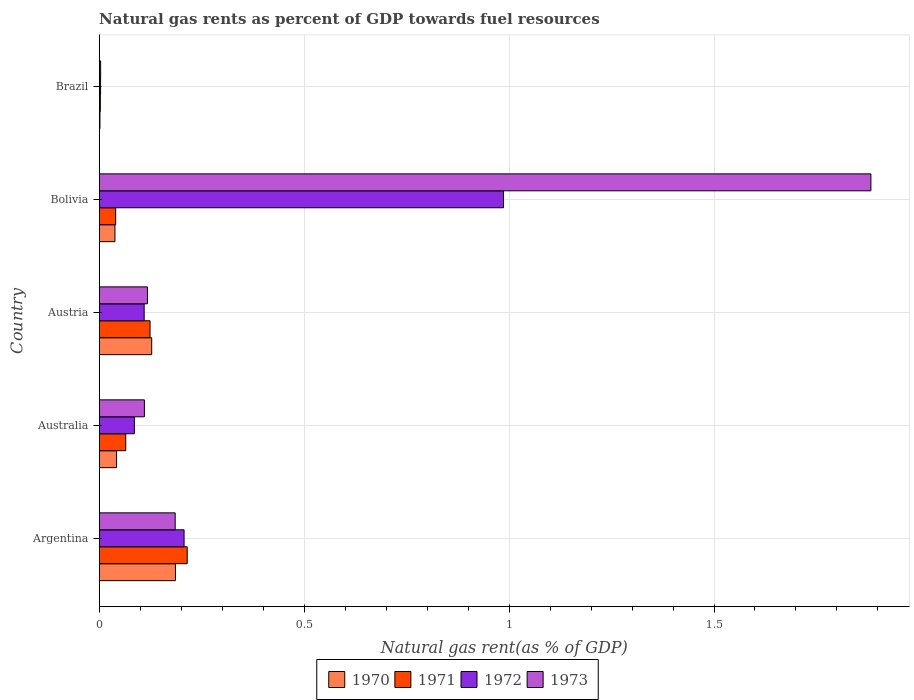How many different coloured bars are there?
Provide a succinct answer. 4. Are the number of bars on each tick of the Y-axis equal?
Keep it short and to the point. Yes. How many bars are there on the 2nd tick from the top?
Make the answer very short. 4. How many bars are there on the 4th tick from the bottom?
Ensure brevity in your answer.  4. In how many cases, is the number of bars for a given country not equal to the number of legend labels?
Your answer should be very brief. 0. What is the natural gas rent in 1972 in Bolivia?
Offer a terse response. 0.99. Across all countries, what is the maximum natural gas rent in 1972?
Your answer should be compact. 0.99. Across all countries, what is the minimum natural gas rent in 1970?
Provide a succinct answer. 0. What is the total natural gas rent in 1971 in the graph?
Offer a very short reply. 0.45. What is the difference between the natural gas rent in 1972 in Argentina and that in Australia?
Your response must be concise. 0.12. What is the difference between the natural gas rent in 1971 in Bolivia and the natural gas rent in 1970 in Argentina?
Offer a very short reply. -0.15. What is the average natural gas rent in 1972 per country?
Your answer should be compact. 0.28. What is the difference between the natural gas rent in 1970 and natural gas rent in 1972 in Bolivia?
Offer a very short reply. -0.95. What is the ratio of the natural gas rent in 1970 in Argentina to that in Brazil?
Offer a terse response. 104.59. Is the natural gas rent in 1970 in Australia less than that in Brazil?
Provide a succinct answer. No. Is the difference between the natural gas rent in 1970 in Australia and Bolivia greater than the difference between the natural gas rent in 1972 in Australia and Bolivia?
Offer a very short reply. Yes. What is the difference between the highest and the second highest natural gas rent in 1971?
Your response must be concise. 0.09. What is the difference between the highest and the lowest natural gas rent in 1973?
Keep it short and to the point. 1.88. Is the sum of the natural gas rent in 1973 in Australia and Austria greater than the maximum natural gas rent in 1970 across all countries?
Your response must be concise. Yes. What does the 4th bar from the bottom in Brazil represents?
Your response must be concise. 1973. How many bars are there?
Offer a terse response. 20. Are all the bars in the graph horizontal?
Offer a very short reply. Yes. Are the values on the major ticks of X-axis written in scientific E-notation?
Make the answer very short. No. Where does the legend appear in the graph?
Your answer should be compact. Bottom center. How many legend labels are there?
Offer a very short reply. 4. What is the title of the graph?
Ensure brevity in your answer.  Natural gas rents as percent of GDP towards fuel resources. Does "1971" appear as one of the legend labels in the graph?
Your answer should be compact. Yes. What is the label or title of the X-axis?
Offer a terse response. Natural gas rent(as % of GDP). What is the label or title of the Y-axis?
Your answer should be compact. Country. What is the Natural gas rent(as % of GDP) of 1970 in Argentina?
Provide a succinct answer. 0.19. What is the Natural gas rent(as % of GDP) in 1971 in Argentina?
Provide a succinct answer. 0.21. What is the Natural gas rent(as % of GDP) in 1972 in Argentina?
Your response must be concise. 0.21. What is the Natural gas rent(as % of GDP) in 1973 in Argentina?
Provide a short and direct response. 0.19. What is the Natural gas rent(as % of GDP) of 1970 in Australia?
Keep it short and to the point. 0.04. What is the Natural gas rent(as % of GDP) of 1971 in Australia?
Keep it short and to the point. 0.06. What is the Natural gas rent(as % of GDP) of 1972 in Australia?
Keep it short and to the point. 0.09. What is the Natural gas rent(as % of GDP) of 1973 in Australia?
Your response must be concise. 0.11. What is the Natural gas rent(as % of GDP) in 1970 in Austria?
Your answer should be compact. 0.13. What is the Natural gas rent(as % of GDP) in 1971 in Austria?
Your answer should be very brief. 0.12. What is the Natural gas rent(as % of GDP) in 1972 in Austria?
Give a very brief answer. 0.11. What is the Natural gas rent(as % of GDP) in 1973 in Austria?
Your answer should be compact. 0.12. What is the Natural gas rent(as % of GDP) in 1970 in Bolivia?
Make the answer very short. 0.04. What is the Natural gas rent(as % of GDP) in 1971 in Bolivia?
Keep it short and to the point. 0.04. What is the Natural gas rent(as % of GDP) of 1972 in Bolivia?
Your answer should be compact. 0.99. What is the Natural gas rent(as % of GDP) in 1973 in Bolivia?
Offer a terse response. 1.88. What is the Natural gas rent(as % of GDP) in 1970 in Brazil?
Your answer should be compact. 0. What is the Natural gas rent(as % of GDP) in 1971 in Brazil?
Offer a very short reply. 0. What is the Natural gas rent(as % of GDP) in 1972 in Brazil?
Ensure brevity in your answer.  0. What is the Natural gas rent(as % of GDP) in 1973 in Brazil?
Provide a short and direct response. 0. Across all countries, what is the maximum Natural gas rent(as % of GDP) of 1970?
Your answer should be compact. 0.19. Across all countries, what is the maximum Natural gas rent(as % of GDP) in 1971?
Give a very brief answer. 0.21. Across all countries, what is the maximum Natural gas rent(as % of GDP) of 1972?
Keep it short and to the point. 0.99. Across all countries, what is the maximum Natural gas rent(as % of GDP) in 1973?
Your response must be concise. 1.88. Across all countries, what is the minimum Natural gas rent(as % of GDP) of 1970?
Your response must be concise. 0. Across all countries, what is the minimum Natural gas rent(as % of GDP) in 1971?
Your answer should be compact. 0. Across all countries, what is the minimum Natural gas rent(as % of GDP) of 1972?
Your response must be concise. 0. Across all countries, what is the minimum Natural gas rent(as % of GDP) in 1973?
Ensure brevity in your answer.  0. What is the total Natural gas rent(as % of GDP) in 1970 in the graph?
Provide a short and direct response. 0.4. What is the total Natural gas rent(as % of GDP) in 1971 in the graph?
Ensure brevity in your answer.  0.45. What is the total Natural gas rent(as % of GDP) of 1972 in the graph?
Your answer should be very brief. 1.39. What is the total Natural gas rent(as % of GDP) of 1973 in the graph?
Provide a succinct answer. 2.3. What is the difference between the Natural gas rent(as % of GDP) of 1970 in Argentina and that in Australia?
Offer a very short reply. 0.14. What is the difference between the Natural gas rent(as % of GDP) of 1971 in Argentina and that in Australia?
Provide a succinct answer. 0.15. What is the difference between the Natural gas rent(as % of GDP) in 1972 in Argentina and that in Australia?
Your answer should be compact. 0.12. What is the difference between the Natural gas rent(as % of GDP) of 1973 in Argentina and that in Australia?
Provide a short and direct response. 0.08. What is the difference between the Natural gas rent(as % of GDP) of 1970 in Argentina and that in Austria?
Offer a very short reply. 0.06. What is the difference between the Natural gas rent(as % of GDP) of 1971 in Argentina and that in Austria?
Offer a very short reply. 0.09. What is the difference between the Natural gas rent(as % of GDP) of 1972 in Argentina and that in Austria?
Offer a terse response. 0.1. What is the difference between the Natural gas rent(as % of GDP) of 1973 in Argentina and that in Austria?
Provide a succinct answer. 0.07. What is the difference between the Natural gas rent(as % of GDP) in 1970 in Argentina and that in Bolivia?
Give a very brief answer. 0.15. What is the difference between the Natural gas rent(as % of GDP) in 1971 in Argentina and that in Bolivia?
Give a very brief answer. 0.17. What is the difference between the Natural gas rent(as % of GDP) of 1972 in Argentina and that in Bolivia?
Offer a terse response. -0.78. What is the difference between the Natural gas rent(as % of GDP) of 1973 in Argentina and that in Bolivia?
Make the answer very short. -1.7. What is the difference between the Natural gas rent(as % of GDP) of 1970 in Argentina and that in Brazil?
Your answer should be very brief. 0.18. What is the difference between the Natural gas rent(as % of GDP) in 1971 in Argentina and that in Brazil?
Your answer should be very brief. 0.21. What is the difference between the Natural gas rent(as % of GDP) in 1972 in Argentina and that in Brazil?
Provide a short and direct response. 0.2. What is the difference between the Natural gas rent(as % of GDP) of 1973 in Argentina and that in Brazil?
Provide a short and direct response. 0.18. What is the difference between the Natural gas rent(as % of GDP) in 1970 in Australia and that in Austria?
Offer a very short reply. -0.09. What is the difference between the Natural gas rent(as % of GDP) of 1971 in Australia and that in Austria?
Ensure brevity in your answer.  -0.06. What is the difference between the Natural gas rent(as % of GDP) of 1972 in Australia and that in Austria?
Your answer should be compact. -0.02. What is the difference between the Natural gas rent(as % of GDP) in 1973 in Australia and that in Austria?
Your answer should be very brief. -0.01. What is the difference between the Natural gas rent(as % of GDP) in 1970 in Australia and that in Bolivia?
Offer a very short reply. 0. What is the difference between the Natural gas rent(as % of GDP) of 1971 in Australia and that in Bolivia?
Your answer should be very brief. 0.02. What is the difference between the Natural gas rent(as % of GDP) in 1972 in Australia and that in Bolivia?
Provide a succinct answer. -0.9. What is the difference between the Natural gas rent(as % of GDP) of 1973 in Australia and that in Bolivia?
Your answer should be very brief. -1.77. What is the difference between the Natural gas rent(as % of GDP) of 1970 in Australia and that in Brazil?
Your answer should be very brief. 0.04. What is the difference between the Natural gas rent(as % of GDP) in 1971 in Australia and that in Brazil?
Keep it short and to the point. 0.06. What is the difference between the Natural gas rent(as % of GDP) of 1972 in Australia and that in Brazil?
Keep it short and to the point. 0.08. What is the difference between the Natural gas rent(as % of GDP) of 1973 in Australia and that in Brazil?
Make the answer very short. 0.11. What is the difference between the Natural gas rent(as % of GDP) of 1970 in Austria and that in Bolivia?
Your answer should be very brief. 0.09. What is the difference between the Natural gas rent(as % of GDP) in 1971 in Austria and that in Bolivia?
Ensure brevity in your answer.  0.08. What is the difference between the Natural gas rent(as % of GDP) in 1972 in Austria and that in Bolivia?
Give a very brief answer. -0.88. What is the difference between the Natural gas rent(as % of GDP) of 1973 in Austria and that in Bolivia?
Make the answer very short. -1.77. What is the difference between the Natural gas rent(as % of GDP) of 1970 in Austria and that in Brazil?
Your answer should be compact. 0.13. What is the difference between the Natural gas rent(as % of GDP) of 1971 in Austria and that in Brazil?
Give a very brief answer. 0.12. What is the difference between the Natural gas rent(as % of GDP) in 1972 in Austria and that in Brazil?
Make the answer very short. 0.11. What is the difference between the Natural gas rent(as % of GDP) of 1973 in Austria and that in Brazil?
Offer a terse response. 0.11. What is the difference between the Natural gas rent(as % of GDP) in 1970 in Bolivia and that in Brazil?
Your answer should be compact. 0.04. What is the difference between the Natural gas rent(as % of GDP) of 1971 in Bolivia and that in Brazil?
Your answer should be very brief. 0.04. What is the difference between the Natural gas rent(as % of GDP) in 1973 in Bolivia and that in Brazil?
Your answer should be very brief. 1.88. What is the difference between the Natural gas rent(as % of GDP) in 1970 in Argentina and the Natural gas rent(as % of GDP) in 1971 in Australia?
Keep it short and to the point. 0.12. What is the difference between the Natural gas rent(as % of GDP) of 1970 in Argentina and the Natural gas rent(as % of GDP) of 1972 in Australia?
Provide a succinct answer. 0.1. What is the difference between the Natural gas rent(as % of GDP) of 1970 in Argentina and the Natural gas rent(as % of GDP) of 1973 in Australia?
Your answer should be very brief. 0.08. What is the difference between the Natural gas rent(as % of GDP) of 1971 in Argentina and the Natural gas rent(as % of GDP) of 1972 in Australia?
Offer a very short reply. 0.13. What is the difference between the Natural gas rent(as % of GDP) in 1971 in Argentina and the Natural gas rent(as % of GDP) in 1973 in Australia?
Provide a short and direct response. 0.1. What is the difference between the Natural gas rent(as % of GDP) of 1972 in Argentina and the Natural gas rent(as % of GDP) of 1973 in Australia?
Offer a very short reply. 0.1. What is the difference between the Natural gas rent(as % of GDP) of 1970 in Argentina and the Natural gas rent(as % of GDP) of 1971 in Austria?
Offer a very short reply. 0.06. What is the difference between the Natural gas rent(as % of GDP) of 1970 in Argentina and the Natural gas rent(as % of GDP) of 1972 in Austria?
Offer a terse response. 0.08. What is the difference between the Natural gas rent(as % of GDP) in 1970 in Argentina and the Natural gas rent(as % of GDP) in 1973 in Austria?
Offer a very short reply. 0.07. What is the difference between the Natural gas rent(as % of GDP) of 1971 in Argentina and the Natural gas rent(as % of GDP) of 1972 in Austria?
Provide a succinct answer. 0.1. What is the difference between the Natural gas rent(as % of GDP) in 1971 in Argentina and the Natural gas rent(as % of GDP) in 1973 in Austria?
Provide a short and direct response. 0.1. What is the difference between the Natural gas rent(as % of GDP) of 1972 in Argentina and the Natural gas rent(as % of GDP) of 1973 in Austria?
Provide a short and direct response. 0.09. What is the difference between the Natural gas rent(as % of GDP) of 1970 in Argentina and the Natural gas rent(as % of GDP) of 1971 in Bolivia?
Your answer should be compact. 0.15. What is the difference between the Natural gas rent(as % of GDP) of 1970 in Argentina and the Natural gas rent(as % of GDP) of 1972 in Bolivia?
Your answer should be compact. -0.8. What is the difference between the Natural gas rent(as % of GDP) in 1970 in Argentina and the Natural gas rent(as % of GDP) in 1973 in Bolivia?
Your response must be concise. -1.7. What is the difference between the Natural gas rent(as % of GDP) of 1971 in Argentina and the Natural gas rent(as % of GDP) of 1972 in Bolivia?
Provide a short and direct response. -0.77. What is the difference between the Natural gas rent(as % of GDP) in 1971 in Argentina and the Natural gas rent(as % of GDP) in 1973 in Bolivia?
Make the answer very short. -1.67. What is the difference between the Natural gas rent(as % of GDP) of 1972 in Argentina and the Natural gas rent(as % of GDP) of 1973 in Bolivia?
Keep it short and to the point. -1.68. What is the difference between the Natural gas rent(as % of GDP) in 1970 in Argentina and the Natural gas rent(as % of GDP) in 1971 in Brazil?
Provide a succinct answer. 0.18. What is the difference between the Natural gas rent(as % of GDP) of 1970 in Argentina and the Natural gas rent(as % of GDP) of 1972 in Brazil?
Make the answer very short. 0.18. What is the difference between the Natural gas rent(as % of GDP) in 1970 in Argentina and the Natural gas rent(as % of GDP) in 1973 in Brazil?
Offer a terse response. 0.18. What is the difference between the Natural gas rent(as % of GDP) in 1971 in Argentina and the Natural gas rent(as % of GDP) in 1972 in Brazil?
Offer a terse response. 0.21. What is the difference between the Natural gas rent(as % of GDP) of 1971 in Argentina and the Natural gas rent(as % of GDP) of 1973 in Brazil?
Give a very brief answer. 0.21. What is the difference between the Natural gas rent(as % of GDP) in 1972 in Argentina and the Natural gas rent(as % of GDP) in 1973 in Brazil?
Keep it short and to the point. 0.2. What is the difference between the Natural gas rent(as % of GDP) in 1970 in Australia and the Natural gas rent(as % of GDP) in 1971 in Austria?
Provide a succinct answer. -0.08. What is the difference between the Natural gas rent(as % of GDP) in 1970 in Australia and the Natural gas rent(as % of GDP) in 1972 in Austria?
Make the answer very short. -0.07. What is the difference between the Natural gas rent(as % of GDP) in 1970 in Australia and the Natural gas rent(as % of GDP) in 1973 in Austria?
Ensure brevity in your answer.  -0.08. What is the difference between the Natural gas rent(as % of GDP) of 1971 in Australia and the Natural gas rent(as % of GDP) of 1972 in Austria?
Give a very brief answer. -0.04. What is the difference between the Natural gas rent(as % of GDP) of 1971 in Australia and the Natural gas rent(as % of GDP) of 1973 in Austria?
Your response must be concise. -0.05. What is the difference between the Natural gas rent(as % of GDP) in 1972 in Australia and the Natural gas rent(as % of GDP) in 1973 in Austria?
Your answer should be compact. -0.03. What is the difference between the Natural gas rent(as % of GDP) of 1970 in Australia and the Natural gas rent(as % of GDP) of 1971 in Bolivia?
Your answer should be compact. 0. What is the difference between the Natural gas rent(as % of GDP) of 1970 in Australia and the Natural gas rent(as % of GDP) of 1972 in Bolivia?
Give a very brief answer. -0.94. What is the difference between the Natural gas rent(as % of GDP) in 1970 in Australia and the Natural gas rent(as % of GDP) in 1973 in Bolivia?
Provide a short and direct response. -1.84. What is the difference between the Natural gas rent(as % of GDP) of 1971 in Australia and the Natural gas rent(as % of GDP) of 1972 in Bolivia?
Make the answer very short. -0.92. What is the difference between the Natural gas rent(as % of GDP) in 1971 in Australia and the Natural gas rent(as % of GDP) in 1973 in Bolivia?
Make the answer very short. -1.82. What is the difference between the Natural gas rent(as % of GDP) in 1972 in Australia and the Natural gas rent(as % of GDP) in 1973 in Bolivia?
Offer a terse response. -1.8. What is the difference between the Natural gas rent(as % of GDP) in 1970 in Australia and the Natural gas rent(as % of GDP) in 1971 in Brazil?
Offer a very short reply. 0.04. What is the difference between the Natural gas rent(as % of GDP) of 1970 in Australia and the Natural gas rent(as % of GDP) of 1972 in Brazil?
Keep it short and to the point. 0.04. What is the difference between the Natural gas rent(as % of GDP) of 1970 in Australia and the Natural gas rent(as % of GDP) of 1973 in Brazil?
Your answer should be compact. 0.04. What is the difference between the Natural gas rent(as % of GDP) of 1971 in Australia and the Natural gas rent(as % of GDP) of 1972 in Brazil?
Provide a succinct answer. 0.06. What is the difference between the Natural gas rent(as % of GDP) of 1971 in Australia and the Natural gas rent(as % of GDP) of 1973 in Brazil?
Your answer should be very brief. 0.06. What is the difference between the Natural gas rent(as % of GDP) of 1972 in Australia and the Natural gas rent(as % of GDP) of 1973 in Brazil?
Your answer should be compact. 0.08. What is the difference between the Natural gas rent(as % of GDP) in 1970 in Austria and the Natural gas rent(as % of GDP) in 1971 in Bolivia?
Keep it short and to the point. 0.09. What is the difference between the Natural gas rent(as % of GDP) of 1970 in Austria and the Natural gas rent(as % of GDP) of 1972 in Bolivia?
Provide a short and direct response. -0.86. What is the difference between the Natural gas rent(as % of GDP) of 1970 in Austria and the Natural gas rent(as % of GDP) of 1973 in Bolivia?
Ensure brevity in your answer.  -1.75. What is the difference between the Natural gas rent(as % of GDP) of 1971 in Austria and the Natural gas rent(as % of GDP) of 1972 in Bolivia?
Offer a terse response. -0.86. What is the difference between the Natural gas rent(as % of GDP) of 1971 in Austria and the Natural gas rent(as % of GDP) of 1973 in Bolivia?
Keep it short and to the point. -1.76. What is the difference between the Natural gas rent(as % of GDP) in 1972 in Austria and the Natural gas rent(as % of GDP) in 1973 in Bolivia?
Give a very brief answer. -1.77. What is the difference between the Natural gas rent(as % of GDP) in 1970 in Austria and the Natural gas rent(as % of GDP) in 1971 in Brazil?
Give a very brief answer. 0.13. What is the difference between the Natural gas rent(as % of GDP) in 1970 in Austria and the Natural gas rent(as % of GDP) in 1972 in Brazil?
Ensure brevity in your answer.  0.12. What is the difference between the Natural gas rent(as % of GDP) of 1970 in Austria and the Natural gas rent(as % of GDP) of 1973 in Brazil?
Your answer should be compact. 0.12. What is the difference between the Natural gas rent(as % of GDP) in 1971 in Austria and the Natural gas rent(as % of GDP) in 1972 in Brazil?
Make the answer very short. 0.12. What is the difference between the Natural gas rent(as % of GDP) of 1971 in Austria and the Natural gas rent(as % of GDP) of 1973 in Brazil?
Provide a short and direct response. 0.12. What is the difference between the Natural gas rent(as % of GDP) in 1972 in Austria and the Natural gas rent(as % of GDP) in 1973 in Brazil?
Give a very brief answer. 0.11. What is the difference between the Natural gas rent(as % of GDP) in 1970 in Bolivia and the Natural gas rent(as % of GDP) in 1971 in Brazil?
Your response must be concise. 0.04. What is the difference between the Natural gas rent(as % of GDP) of 1970 in Bolivia and the Natural gas rent(as % of GDP) of 1972 in Brazil?
Make the answer very short. 0.04. What is the difference between the Natural gas rent(as % of GDP) in 1970 in Bolivia and the Natural gas rent(as % of GDP) in 1973 in Brazil?
Offer a very short reply. 0.03. What is the difference between the Natural gas rent(as % of GDP) in 1971 in Bolivia and the Natural gas rent(as % of GDP) in 1972 in Brazil?
Your response must be concise. 0.04. What is the difference between the Natural gas rent(as % of GDP) of 1971 in Bolivia and the Natural gas rent(as % of GDP) of 1973 in Brazil?
Provide a short and direct response. 0.04. What is the difference between the Natural gas rent(as % of GDP) of 1972 in Bolivia and the Natural gas rent(as % of GDP) of 1973 in Brazil?
Give a very brief answer. 0.98. What is the average Natural gas rent(as % of GDP) of 1970 per country?
Provide a short and direct response. 0.08. What is the average Natural gas rent(as % of GDP) in 1971 per country?
Provide a succinct answer. 0.09. What is the average Natural gas rent(as % of GDP) in 1972 per country?
Offer a very short reply. 0.28. What is the average Natural gas rent(as % of GDP) in 1973 per country?
Your response must be concise. 0.46. What is the difference between the Natural gas rent(as % of GDP) of 1970 and Natural gas rent(as % of GDP) of 1971 in Argentina?
Keep it short and to the point. -0.03. What is the difference between the Natural gas rent(as % of GDP) in 1970 and Natural gas rent(as % of GDP) in 1972 in Argentina?
Your response must be concise. -0.02. What is the difference between the Natural gas rent(as % of GDP) of 1970 and Natural gas rent(as % of GDP) of 1973 in Argentina?
Provide a short and direct response. 0. What is the difference between the Natural gas rent(as % of GDP) in 1971 and Natural gas rent(as % of GDP) in 1972 in Argentina?
Provide a short and direct response. 0.01. What is the difference between the Natural gas rent(as % of GDP) in 1971 and Natural gas rent(as % of GDP) in 1973 in Argentina?
Provide a succinct answer. 0.03. What is the difference between the Natural gas rent(as % of GDP) of 1972 and Natural gas rent(as % of GDP) of 1973 in Argentina?
Your response must be concise. 0.02. What is the difference between the Natural gas rent(as % of GDP) in 1970 and Natural gas rent(as % of GDP) in 1971 in Australia?
Offer a very short reply. -0.02. What is the difference between the Natural gas rent(as % of GDP) of 1970 and Natural gas rent(as % of GDP) of 1972 in Australia?
Offer a very short reply. -0.04. What is the difference between the Natural gas rent(as % of GDP) in 1970 and Natural gas rent(as % of GDP) in 1973 in Australia?
Make the answer very short. -0.07. What is the difference between the Natural gas rent(as % of GDP) of 1971 and Natural gas rent(as % of GDP) of 1972 in Australia?
Your answer should be very brief. -0.02. What is the difference between the Natural gas rent(as % of GDP) of 1971 and Natural gas rent(as % of GDP) of 1973 in Australia?
Provide a short and direct response. -0.05. What is the difference between the Natural gas rent(as % of GDP) in 1972 and Natural gas rent(as % of GDP) in 1973 in Australia?
Offer a very short reply. -0.02. What is the difference between the Natural gas rent(as % of GDP) in 1970 and Natural gas rent(as % of GDP) in 1971 in Austria?
Give a very brief answer. 0. What is the difference between the Natural gas rent(as % of GDP) in 1970 and Natural gas rent(as % of GDP) in 1972 in Austria?
Keep it short and to the point. 0.02. What is the difference between the Natural gas rent(as % of GDP) of 1970 and Natural gas rent(as % of GDP) of 1973 in Austria?
Ensure brevity in your answer.  0.01. What is the difference between the Natural gas rent(as % of GDP) of 1971 and Natural gas rent(as % of GDP) of 1972 in Austria?
Offer a terse response. 0.01. What is the difference between the Natural gas rent(as % of GDP) of 1971 and Natural gas rent(as % of GDP) of 1973 in Austria?
Offer a very short reply. 0.01. What is the difference between the Natural gas rent(as % of GDP) of 1972 and Natural gas rent(as % of GDP) of 1973 in Austria?
Keep it short and to the point. -0.01. What is the difference between the Natural gas rent(as % of GDP) of 1970 and Natural gas rent(as % of GDP) of 1971 in Bolivia?
Your answer should be compact. -0. What is the difference between the Natural gas rent(as % of GDP) in 1970 and Natural gas rent(as % of GDP) in 1972 in Bolivia?
Offer a terse response. -0.95. What is the difference between the Natural gas rent(as % of GDP) in 1970 and Natural gas rent(as % of GDP) in 1973 in Bolivia?
Your answer should be very brief. -1.84. What is the difference between the Natural gas rent(as % of GDP) of 1971 and Natural gas rent(as % of GDP) of 1972 in Bolivia?
Keep it short and to the point. -0.95. What is the difference between the Natural gas rent(as % of GDP) of 1971 and Natural gas rent(as % of GDP) of 1973 in Bolivia?
Your response must be concise. -1.84. What is the difference between the Natural gas rent(as % of GDP) in 1972 and Natural gas rent(as % of GDP) in 1973 in Bolivia?
Ensure brevity in your answer.  -0.9. What is the difference between the Natural gas rent(as % of GDP) of 1970 and Natural gas rent(as % of GDP) of 1971 in Brazil?
Ensure brevity in your answer.  -0. What is the difference between the Natural gas rent(as % of GDP) in 1970 and Natural gas rent(as % of GDP) in 1972 in Brazil?
Make the answer very short. -0. What is the difference between the Natural gas rent(as % of GDP) of 1970 and Natural gas rent(as % of GDP) of 1973 in Brazil?
Provide a short and direct response. -0. What is the difference between the Natural gas rent(as % of GDP) of 1971 and Natural gas rent(as % of GDP) of 1972 in Brazil?
Make the answer very short. -0. What is the difference between the Natural gas rent(as % of GDP) in 1971 and Natural gas rent(as % of GDP) in 1973 in Brazil?
Provide a short and direct response. -0. What is the difference between the Natural gas rent(as % of GDP) in 1972 and Natural gas rent(as % of GDP) in 1973 in Brazil?
Your answer should be very brief. -0. What is the ratio of the Natural gas rent(as % of GDP) of 1970 in Argentina to that in Australia?
Provide a short and direct response. 4.39. What is the ratio of the Natural gas rent(as % of GDP) in 1971 in Argentina to that in Australia?
Provide a short and direct response. 3.32. What is the ratio of the Natural gas rent(as % of GDP) of 1972 in Argentina to that in Australia?
Give a very brief answer. 2.41. What is the ratio of the Natural gas rent(as % of GDP) in 1973 in Argentina to that in Australia?
Make the answer very short. 1.68. What is the ratio of the Natural gas rent(as % of GDP) in 1970 in Argentina to that in Austria?
Provide a succinct answer. 1.45. What is the ratio of the Natural gas rent(as % of GDP) in 1971 in Argentina to that in Austria?
Keep it short and to the point. 1.73. What is the ratio of the Natural gas rent(as % of GDP) in 1972 in Argentina to that in Austria?
Give a very brief answer. 1.89. What is the ratio of the Natural gas rent(as % of GDP) of 1973 in Argentina to that in Austria?
Offer a very short reply. 1.57. What is the ratio of the Natural gas rent(as % of GDP) in 1970 in Argentina to that in Bolivia?
Your response must be concise. 4.85. What is the ratio of the Natural gas rent(as % of GDP) of 1971 in Argentina to that in Bolivia?
Provide a short and direct response. 5.35. What is the ratio of the Natural gas rent(as % of GDP) in 1972 in Argentina to that in Bolivia?
Provide a succinct answer. 0.21. What is the ratio of the Natural gas rent(as % of GDP) of 1973 in Argentina to that in Bolivia?
Your answer should be very brief. 0.1. What is the ratio of the Natural gas rent(as % of GDP) in 1970 in Argentina to that in Brazil?
Give a very brief answer. 104.59. What is the ratio of the Natural gas rent(as % of GDP) in 1971 in Argentina to that in Brazil?
Your answer should be compact. 78.25. What is the ratio of the Natural gas rent(as % of GDP) in 1972 in Argentina to that in Brazil?
Your answer should be compact. 62.44. What is the ratio of the Natural gas rent(as % of GDP) of 1973 in Argentina to that in Brazil?
Offer a terse response. 53.1. What is the ratio of the Natural gas rent(as % of GDP) of 1970 in Australia to that in Austria?
Ensure brevity in your answer.  0.33. What is the ratio of the Natural gas rent(as % of GDP) of 1971 in Australia to that in Austria?
Offer a terse response. 0.52. What is the ratio of the Natural gas rent(as % of GDP) of 1972 in Australia to that in Austria?
Your response must be concise. 0.78. What is the ratio of the Natural gas rent(as % of GDP) of 1973 in Australia to that in Austria?
Your response must be concise. 0.94. What is the ratio of the Natural gas rent(as % of GDP) in 1970 in Australia to that in Bolivia?
Your response must be concise. 1.1. What is the ratio of the Natural gas rent(as % of GDP) of 1971 in Australia to that in Bolivia?
Provide a succinct answer. 1.61. What is the ratio of the Natural gas rent(as % of GDP) of 1972 in Australia to that in Bolivia?
Your response must be concise. 0.09. What is the ratio of the Natural gas rent(as % of GDP) in 1973 in Australia to that in Bolivia?
Make the answer very short. 0.06. What is the ratio of the Natural gas rent(as % of GDP) in 1970 in Australia to that in Brazil?
Provide a succinct answer. 23.81. What is the ratio of the Natural gas rent(as % of GDP) in 1971 in Australia to that in Brazil?
Your answer should be compact. 23.6. What is the ratio of the Natural gas rent(as % of GDP) of 1972 in Australia to that in Brazil?
Give a very brief answer. 25.86. What is the ratio of the Natural gas rent(as % of GDP) in 1973 in Australia to that in Brazil?
Your answer should be compact. 31.58. What is the ratio of the Natural gas rent(as % of GDP) of 1970 in Austria to that in Bolivia?
Make the answer very short. 3.34. What is the ratio of the Natural gas rent(as % of GDP) in 1971 in Austria to that in Bolivia?
Keep it short and to the point. 3.09. What is the ratio of the Natural gas rent(as % of GDP) in 1972 in Austria to that in Bolivia?
Your answer should be very brief. 0.11. What is the ratio of the Natural gas rent(as % of GDP) of 1973 in Austria to that in Bolivia?
Provide a succinct answer. 0.06. What is the ratio of the Natural gas rent(as % of GDP) in 1970 in Austria to that in Brazil?
Give a very brief answer. 72. What is the ratio of the Natural gas rent(as % of GDP) in 1971 in Austria to that in Brazil?
Ensure brevity in your answer.  45.2. What is the ratio of the Natural gas rent(as % of GDP) in 1972 in Austria to that in Brazil?
Give a very brief answer. 33.07. What is the ratio of the Natural gas rent(as % of GDP) of 1973 in Austria to that in Brazil?
Make the answer very short. 33.74. What is the ratio of the Natural gas rent(as % of GDP) of 1970 in Bolivia to that in Brazil?
Offer a terse response. 21.58. What is the ratio of the Natural gas rent(as % of GDP) of 1971 in Bolivia to that in Brazil?
Offer a terse response. 14.62. What is the ratio of the Natural gas rent(as % of GDP) of 1972 in Bolivia to that in Brazil?
Your response must be concise. 297.41. What is the ratio of the Natural gas rent(as % of GDP) of 1973 in Bolivia to that in Brazil?
Your answer should be very brief. 539.46. What is the difference between the highest and the second highest Natural gas rent(as % of GDP) in 1970?
Keep it short and to the point. 0.06. What is the difference between the highest and the second highest Natural gas rent(as % of GDP) in 1971?
Offer a terse response. 0.09. What is the difference between the highest and the second highest Natural gas rent(as % of GDP) in 1972?
Keep it short and to the point. 0.78. What is the difference between the highest and the second highest Natural gas rent(as % of GDP) in 1973?
Your response must be concise. 1.7. What is the difference between the highest and the lowest Natural gas rent(as % of GDP) in 1970?
Provide a short and direct response. 0.18. What is the difference between the highest and the lowest Natural gas rent(as % of GDP) of 1971?
Your response must be concise. 0.21. What is the difference between the highest and the lowest Natural gas rent(as % of GDP) in 1973?
Offer a terse response. 1.88. 